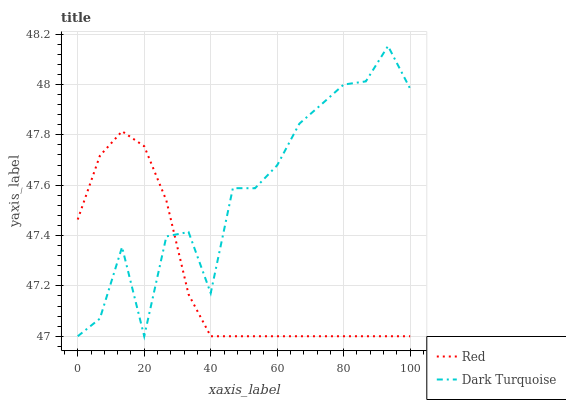Does Red have the minimum area under the curve?
Answer yes or no. Yes. Does Red have the maximum area under the curve?
Answer yes or no. No. Is Red the smoothest?
Answer yes or no. Yes. Is Dark Turquoise the roughest?
Answer yes or no. Yes. Is Red the roughest?
Answer yes or no. No. Does Red have the highest value?
Answer yes or no. No. 